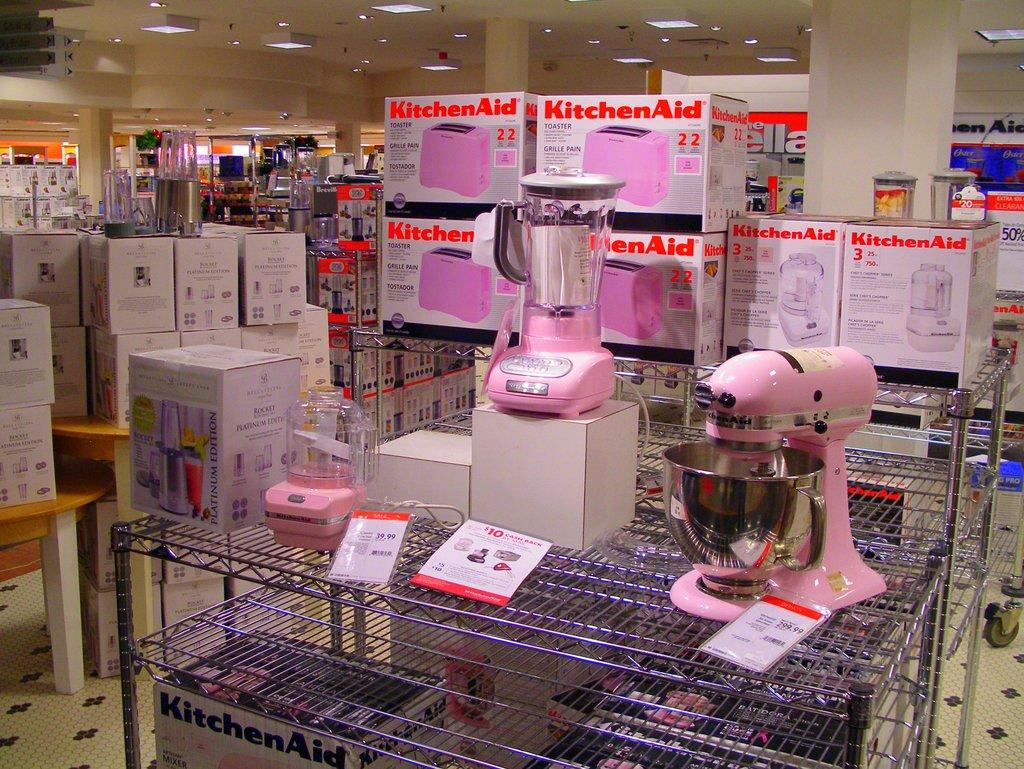<image>
Render a clear and concise summary of the photo. Pink Kitchen Aid brand appliances sit on a wire rack in a store. 